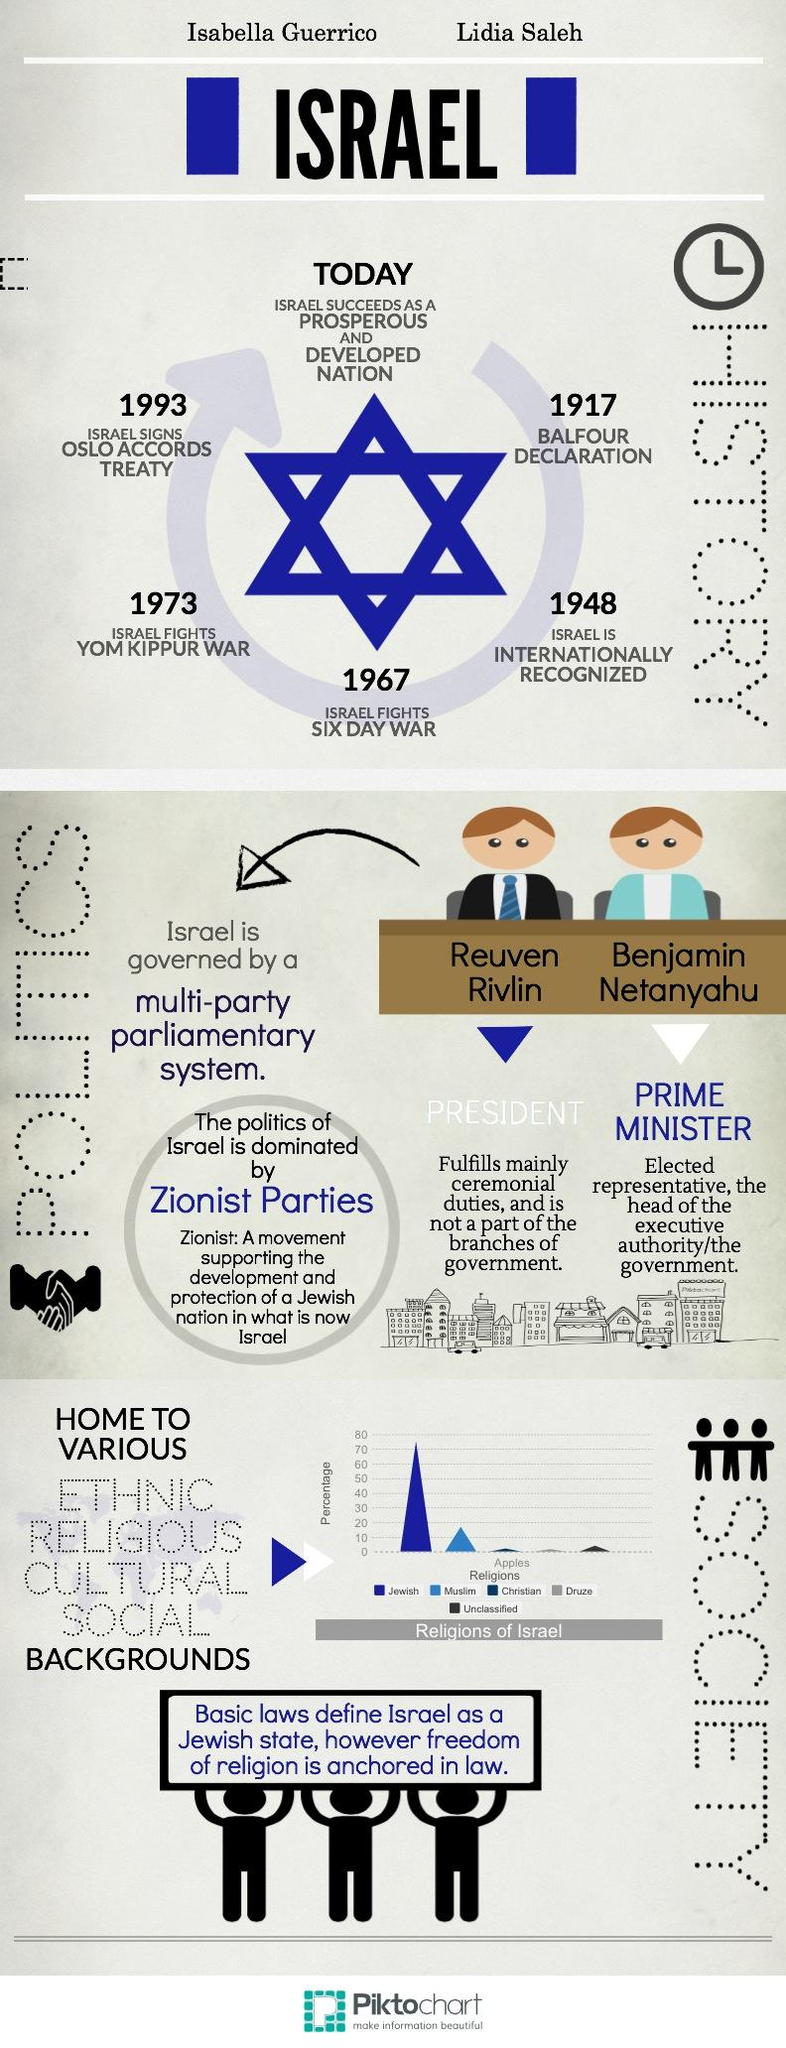Identify some key points in this picture. The Yom Kippur War occurred in the year 1973. The President primarily performs ceremonial duties. The elected representative and head of government is the Prime Minister. The current prime minister of Israel is Benjamin Netanyahu. The Balfour Declaration was made in 1917. 